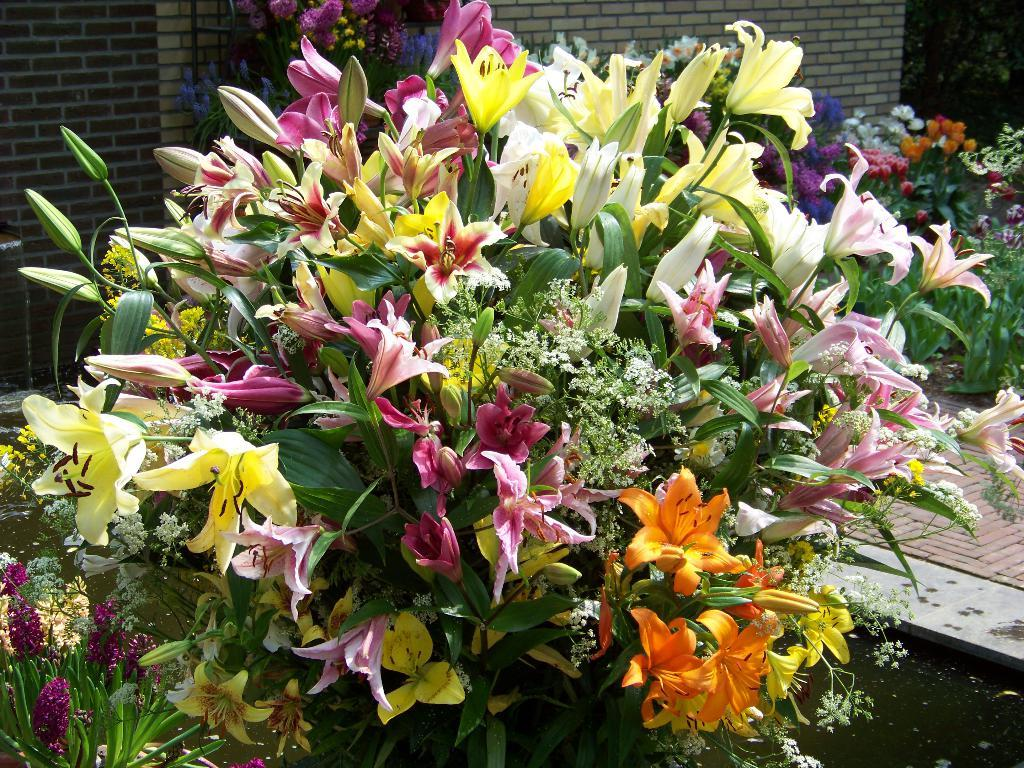What is the main subject of the image? There is a bouquet in the image. What can be seen in the background of the image? There is water visible in the image. What type of living organisms are present in the image? There are plants and flowers in the image. What is the structure visible in the image? There is a wall in the image. How many worms can be seen crawling on the flowers in the image? There are no worms present in the image; it only features a bouquet, water, plants, flowers, and a wall. 